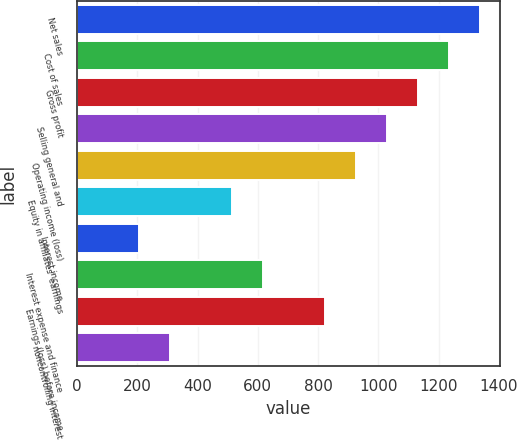<chart> <loc_0><loc_0><loc_500><loc_500><bar_chart><fcel>Net sales<fcel>Cost of sales<fcel>Gross profit<fcel>Selling general and<fcel>Operating income (loss)<fcel>Equity in affiliates' earnings<fcel>Interest income<fcel>Interest expense and finance<fcel>Earnings (loss) before income<fcel>noncontrolling interest<nl><fcel>1336.09<fcel>1233.32<fcel>1130.55<fcel>1027.78<fcel>925.01<fcel>513.95<fcel>205.67<fcel>616.72<fcel>822.25<fcel>308.43<nl></chart> 